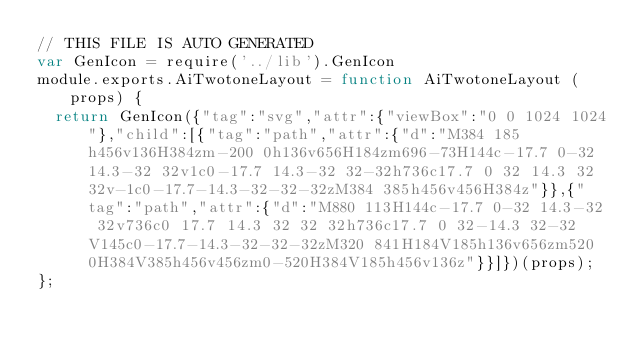<code> <loc_0><loc_0><loc_500><loc_500><_JavaScript_>// THIS FILE IS AUTO GENERATED
var GenIcon = require('../lib').GenIcon
module.exports.AiTwotoneLayout = function AiTwotoneLayout (props) {
  return GenIcon({"tag":"svg","attr":{"viewBox":"0 0 1024 1024"},"child":[{"tag":"path","attr":{"d":"M384 185h456v136H384zm-200 0h136v656H184zm696-73H144c-17.7 0-32 14.3-32 32v1c0-17.7 14.3-32 32-32h736c17.7 0 32 14.3 32 32v-1c0-17.7-14.3-32-32-32zM384 385h456v456H384z"}},{"tag":"path","attr":{"d":"M880 113H144c-17.7 0-32 14.3-32 32v736c0 17.7 14.3 32 32 32h736c17.7 0 32-14.3 32-32V145c0-17.7-14.3-32-32-32zM320 841H184V185h136v656zm520 0H384V385h456v456zm0-520H384V185h456v136z"}}]})(props);
};
</code> 